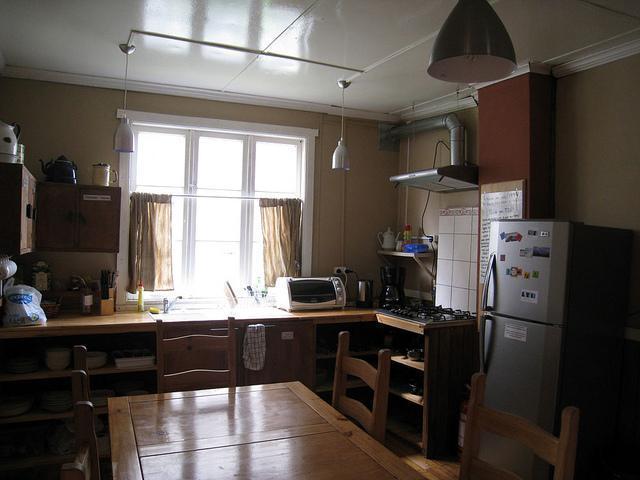How many lights are hanging from the ceiling?
Give a very brief answer. 3. How many lights are on?
Give a very brief answer. 0. How many window panes are they?
Give a very brief answer. 3. How many walls have windows?
Give a very brief answer. 1. How many chairs can be seen?
Give a very brief answer. 4. 